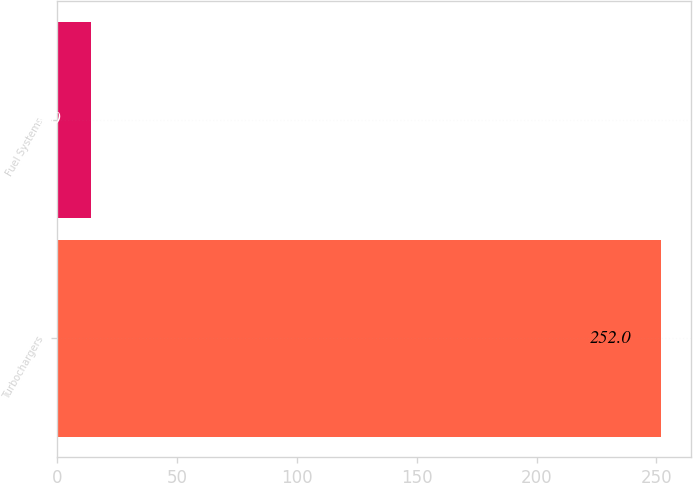<chart> <loc_0><loc_0><loc_500><loc_500><bar_chart><fcel>Turbochargers<fcel>Fuel Systems<nl><fcel>252<fcel>14<nl></chart> 